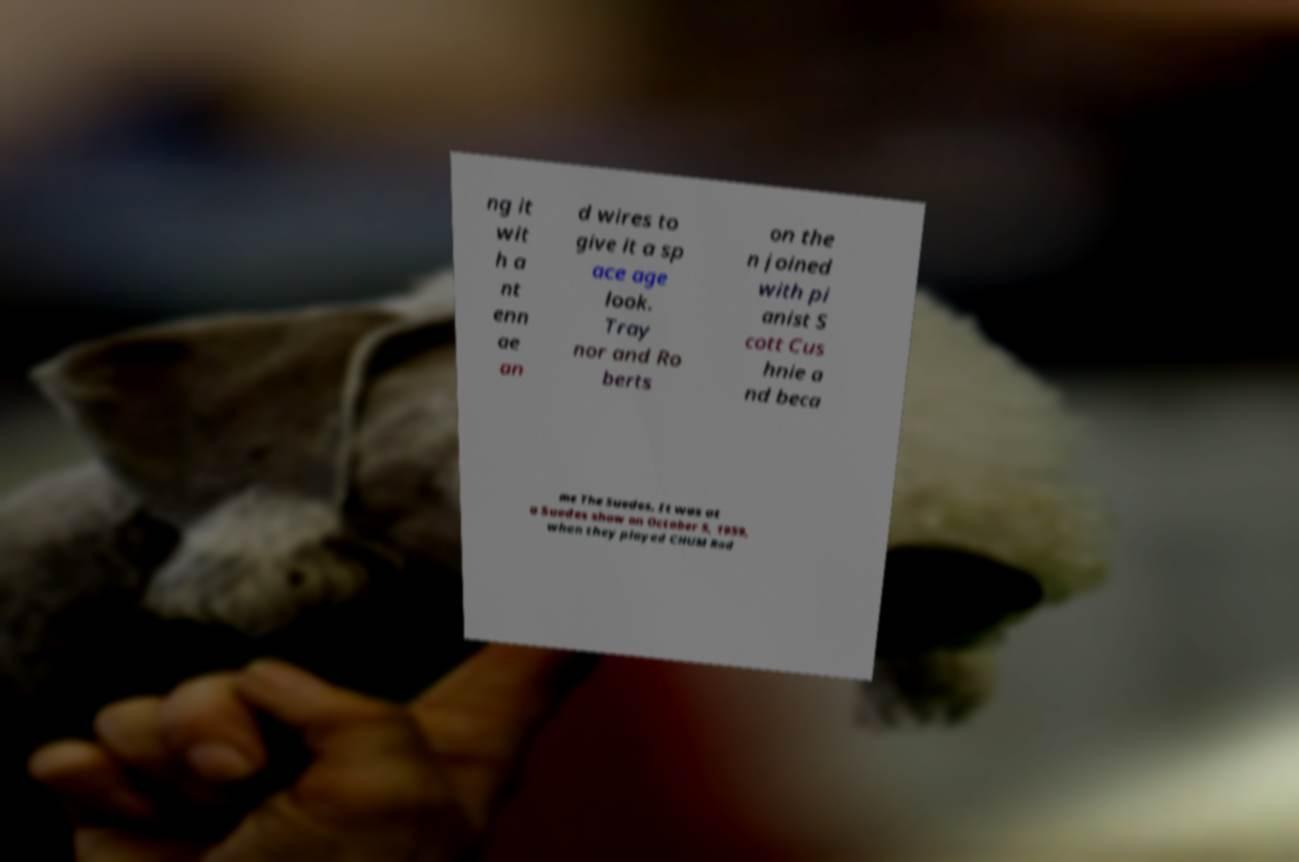There's text embedded in this image that I need extracted. Can you transcribe it verbatim? ng it wit h a nt enn ae an d wires to give it a sp ace age look. Tray nor and Ro berts on the n joined with pi anist S cott Cus hnie a nd beca me The Suedes. It was at a Suedes show on October 5, 1959, when they played CHUM Rad 